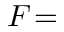<formula> <loc_0><loc_0><loc_500><loc_500>F \, =</formula> 